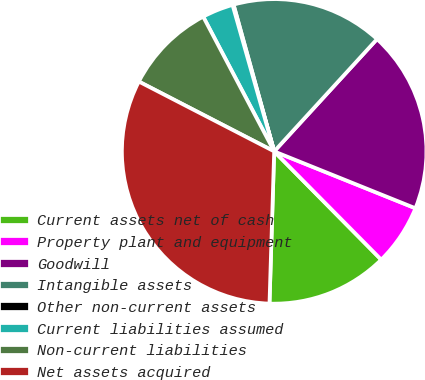Convert chart to OTSL. <chart><loc_0><loc_0><loc_500><loc_500><pie_chart><fcel>Current assets net of cash<fcel>Property plant and equipment<fcel>Goodwill<fcel>Intangible assets<fcel>Other non-current assets<fcel>Current liabilities assumed<fcel>Non-current liabilities<fcel>Net assets acquired<nl><fcel>12.9%<fcel>6.5%<fcel>19.29%<fcel>16.1%<fcel>0.11%<fcel>3.31%<fcel>9.7%<fcel>32.09%<nl></chart> 